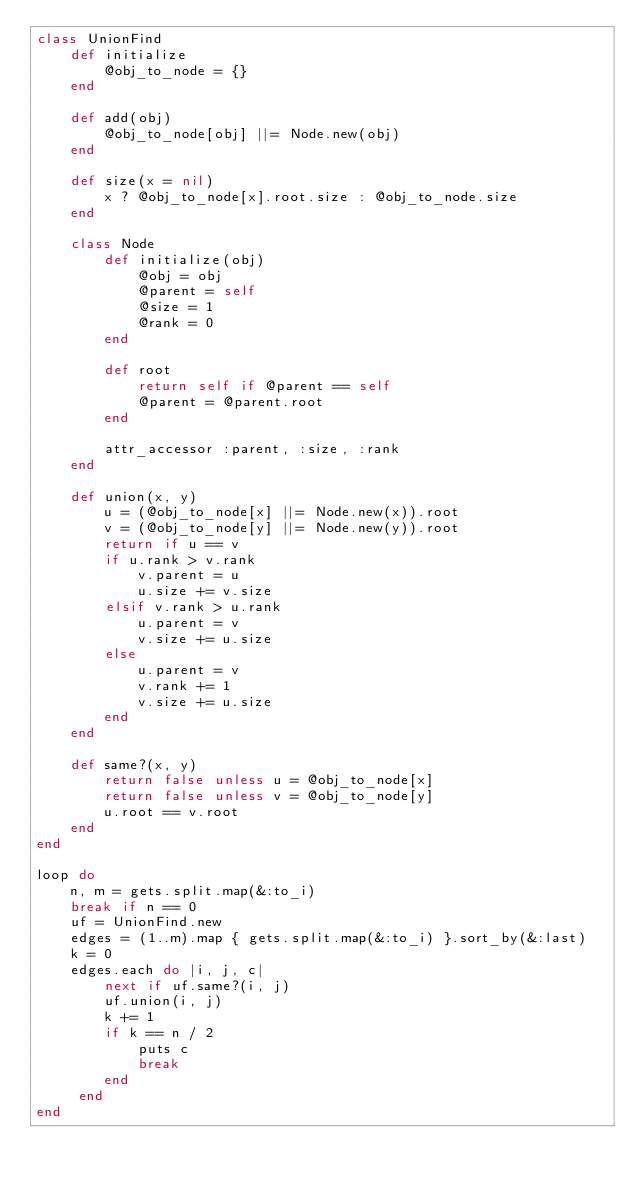<code> <loc_0><loc_0><loc_500><loc_500><_Ruby_>class UnionFind
	def initialize
		@obj_to_node = {}
	end

	def add(obj)
		@obj_to_node[obj] ||= Node.new(obj)
	end

	def size(x = nil)
		x ? @obj_to_node[x].root.size : @obj_to_node.size
	end

	class Node
		def initialize(obj)
			@obj = obj
			@parent = self
			@size = 1
			@rank = 0
		end

		def root
			return self if @parent == self
			@parent = @parent.root
		end	

		attr_accessor :parent, :size, :rank
	end

	def union(x, y)
		u = (@obj_to_node[x] ||= Node.new(x)).root
		v = (@obj_to_node[y] ||= Node.new(y)).root
		return if u == v
		if u.rank > v.rank
			v.parent = u
			u.size += v.size
		elsif v.rank > u.rank
			u.parent = v
			v.size += u.size
		else
			u.parent = v
			v.rank += 1
			v.size += u.size
		end
	end

	def same?(x, y)
		return false unless u = @obj_to_node[x]
		return false unless v = @obj_to_node[y]
		u.root == v.root
	end
end

loop do
	n, m = gets.split.map(&:to_i) 
	break if n == 0
	uf = UnionFind.new
	edges = (1..m).map { gets.split.map(&:to_i) }.sort_by(&:last)
	k = 0
	edges.each do |i, j, c|
		next if uf.same?(i, j)
		uf.union(i, j)
		k += 1
		if k == n / 2
			puts c
			break
		end
	 end
end</code> 